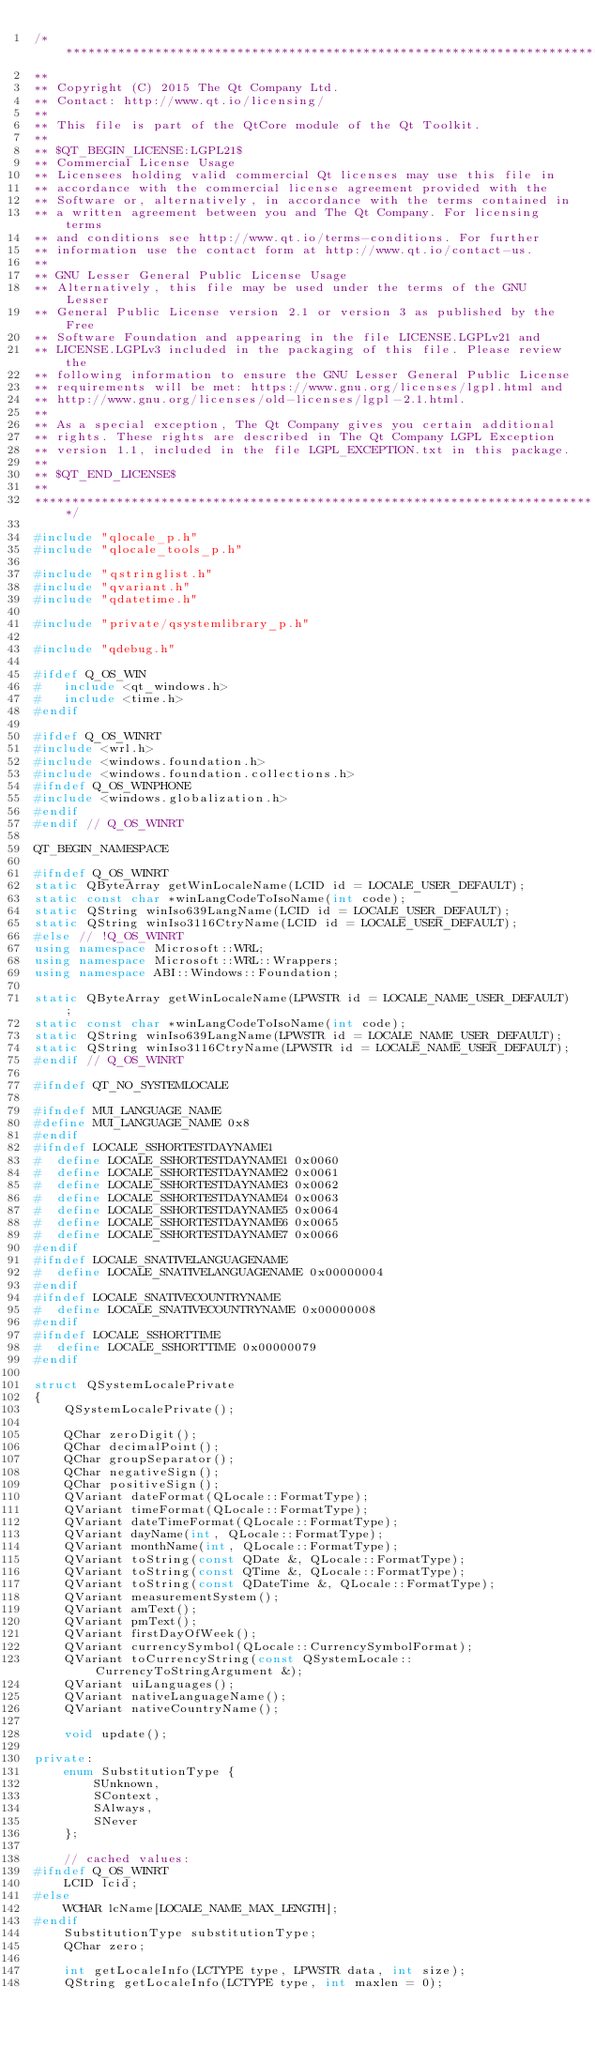Convert code to text. <code><loc_0><loc_0><loc_500><loc_500><_C++_>/****************************************************************************
**
** Copyright (C) 2015 The Qt Company Ltd.
** Contact: http://www.qt.io/licensing/
**
** This file is part of the QtCore module of the Qt Toolkit.
**
** $QT_BEGIN_LICENSE:LGPL21$
** Commercial License Usage
** Licensees holding valid commercial Qt licenses may use this file in
** accordance with the commercial license agreement provided with the
** Software or, alternatively, in accordance with the terms contained in
** a written agreement between you and The Qt Company. For licensing terms
** and conditions see http://www.qt.io/terms-conditions. For further
** information use the contact form at http://www.qt.io/contact-us.
**
** GNU Lesser General Public License Usage
** Alternatively, this file may be used under the terms of the GNU Lesser
** General Public License version 2.1 or version 3 as published by the Free
** Software Foundation and appearing in the file LICENSE.LGPLv21 and
** LICENSE.LGPLv3 included in the packaging of this file. Please review the
** following information to ensure the GNU Lesser General Public License
** requirements will be met: https://www.gnu.org/licenses/lgpl.html and
** http://www.gnu.org/licenses/old-licenses/lgpl-2.1.html.
**
** As a special exception, The Qt Company gives you certain additional
** rights. These rights are described in The Qt Company LGPL Exception
** version 1.1, included in the file LGPL_EXCEPTION.txt in this package.
**
** $QT_END_LICENSE$
**
****************************************************************************/

#include "qlocale_p.h"
#include "qlocale_tools_p.h"

#include "qstringlist.h"
#include "qvariant.h"
#include "qdatetime.h"

#include "private/qsystemlibrary_p.h"

#include "qdebug.h"

#ifdef Q_OS_WIN
#   include <qt_windows.h>
#   include <time.h>
#endif

#ifdef Q_OS_WINRT
#include <wrl.h>
#include <windows.foundation.h>
#include <windows.foundation.collections.h>
#ifndef Q_OS_WINPHONE
#include <windows.globalization.h>
#endif
#endif // Q_OS_WINRT

QT_BEGIN_NAMESPACE

#ifndef Q_OS_WINRT
static QByteArray getWinLocaleName(LCID id = LOCALE_USER_DEFAULT);
static const char *winLangCodeToIsoName(int code);
static QString winIso639LangName(LCID id = LOCALE_USER_DEFAULT);
static QString winIso3116CtryName(LCID id = LOCALE_USER_DEFAULT);
#else // !Q_OS_WINRT
using namespace Microsoft::WRL;
using namespace Microsoft::WRL::Wrappers;
using namespace ABI::Windows::Foundation;

static QByteArray getWinLocaleName(LPWSTR id = LOCALE_NAME_USER_DEFAULT);
static const char *winLangCodeToIsoName(int code);
static QString winIso639LangName(LPWSTR id = LOCALE_NAME_USER_DEFAULT);
static QString winIso3116CtryName(LPWSTR id = LOCALE_NAME_USER_DEFAULT);
#endif // Q_OS_WINRT

#ifndef QT_NO_SYSTEMLOCALE

#ifndef MUI_LANGUAGE_NAME
#define MUI_LANGUAGE_NAME 0x8
#endif
#ifndef LOCALE_SSHORTESTDAYNAME1
#  define LOCALE_SSHORTESTDAYNAME1 0x0060
#  define LOCALE_SSHORTESTDAYNAME2 0x0061
#  define LOCALE_SSHORTESTDAYNAME3 0x0062
#  define LOCALE_SSHORTESTDAYNAME4 0x0063
#  define LOCALE_SSHORTESTDAYNAME5 0x0064
#  define LOCALE_SSHORTESTDAYNAME6 0x0065
#  define LOCALE_SSHORTESTDAYNAME7 0x0066
#endif
#ifndef LOCALE_SNATIVELANGUAGENAME
#  define LOCALE_SNATIVELANGUAGENAME 0x00000004
#endif
#ifndef LOCALE_SNATIVECOUNTRYNAME
#  define LOCALE_SNATIVECOUNTRYNAME 0x00000008
#endif
#ifndef LOCALE_SSHORTTIME
#  define LOCALE_SSHORTTIME 0x00000079
#endif

struct QSystemLocalePrivate
{
    QSystemLocalePrivate();

    QChar zeroDigit();
    QChar decimalPoint();
    QChar groupSeparator();
    QChar negativeSign();
    QChar positiveSign();
    QVariant dateFormat(QLocale::FormatType);
    QVariant timeFormat(QLocale::FormatType);
    QVariant dateTimeFormat(QLocale::FormatType);
    QVariant dayName(int, QLocale::FormatType);
    QVariant monthName(int, QLocale::FormatType);
    QVariant toString(const QDate &, QLocale::FormatType);
    QVariant toString(const QTime &, QLocale::FormatType);
    QVariant toString(const QDateTime &, QLocale::FormatType);
    QVariant measurementSystem();
    QVariant amText();
    QVariant pmText();
    QVariant firstDayOfWeek();
    QVariant currencySymbol(QLocale::CurrencySymbolFormat);
    QVariant toCurrencyString(const QSystemLocale::CurrencyToStringArgument &);
    QVariant uiLanguages();
    QVariant nativeLanguageName();
    QVariant nativeCountryName();

    void update();

private:
    enum SubstitutionType {
        SUnknown,
        SContext,
        SAlways,
        SNever
    };

    // cached values:
#ifndef Q_OS_WINRT
    LCID lcid;
#else
    WCHAR lcName[LOCALE_NAME_MAX_LENGTH];
#endif
    SubstitutionType substitutionType;
    QChar zero;

    int getLocaleInfo(LCTYPE type, LPWSTR data, int size);
    QString getLocaleInfo(LCTYPE type, int maxlen = 0);</code> 